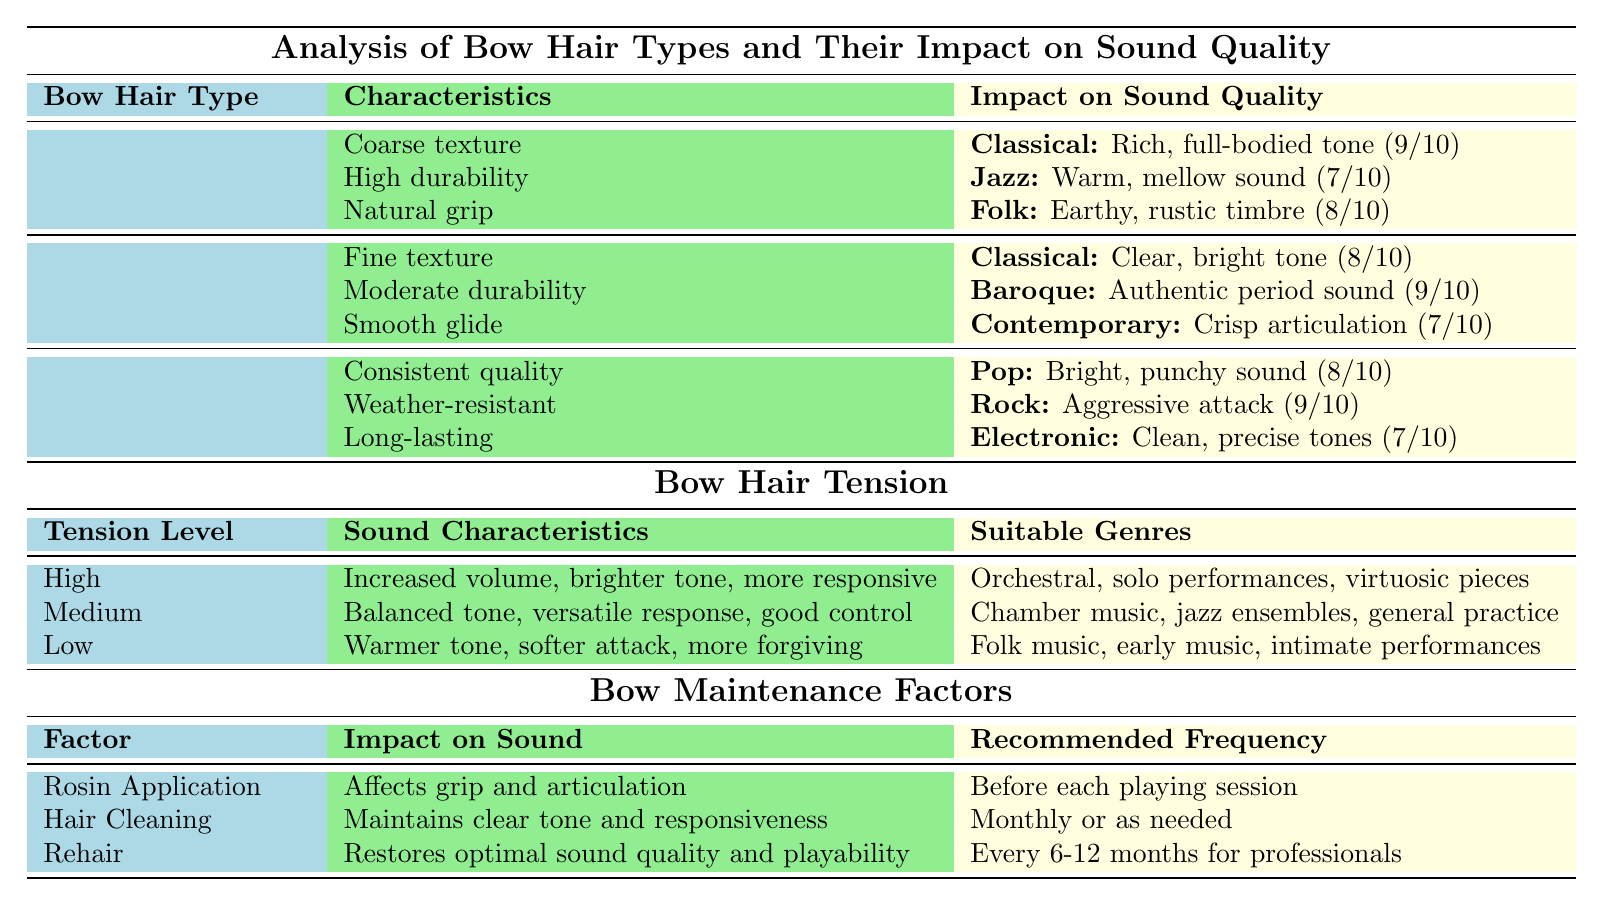What are the characteristics of Synthetic Fiber bow hair? The table lists the characteristics of Synthetic Fiber as consistent quality, weather-resistant, and long-lasting.
Answer: Consistent quality, weather-resistant, long-lasting Which bow hair type is most suitable for Baroque music? The table indicates that Siberian Horse Hair has an effect described as "Authentic period sound" for Baroque music, with a suitability rating of 9.
Answer: Siberian Horse Hair What is the effect of high bow hair tension on sound characteristics? High bow hair tension results in increased volume, a brighter tone, and makes the bow more responsive as per the table's data.
Answer: Increased volume, brighter tone, more responsive Which bow hair type provides a warm, mellow sound for Jazz? Mongolian Horse Hair is identified in the table as providing a warm, mellow sound for Jazz with a suitability rating of 7.
Answer: Mongolian Horse Hair How many genres are suitable for low bow hair tension? The table lists three suitable genres for low bow hair tension: Folk music, early music, and intimate performances.
Answer: Three genres Which bow hair type has the highest suitability rating for Classical music? The table shows that Mongolian Horse Hair has a suitability rating of 9 for Classical music, which is the highest among all mentioned types.
Answer: Mongolian Horse Hair What is the primary impact of rosin application on sound? The table states that rosin application affects grip and articulation, which is crucial for sound quality during play.
Answer: Affects grip and articulation Calculate the average suitability rating for the pop and rock genres. The suitability rating for Pop is 8 and for Rock is 9. The average is (8 + 9) / 2 = 8.5.
Answer: 8.5 Is it true that Synthetic Fiber bow hair is recommended for electronic music? Yes, the table states that Synthetic Fiber bow hair provides clean, precise tones for electronic music.
Answer: Yes Which type of bow hair is characterized as having a coarse texture? The table indicates that Mongolian Horse Hair is characterized by a coarse texture.
Answer: Mongolian Horse Hair 